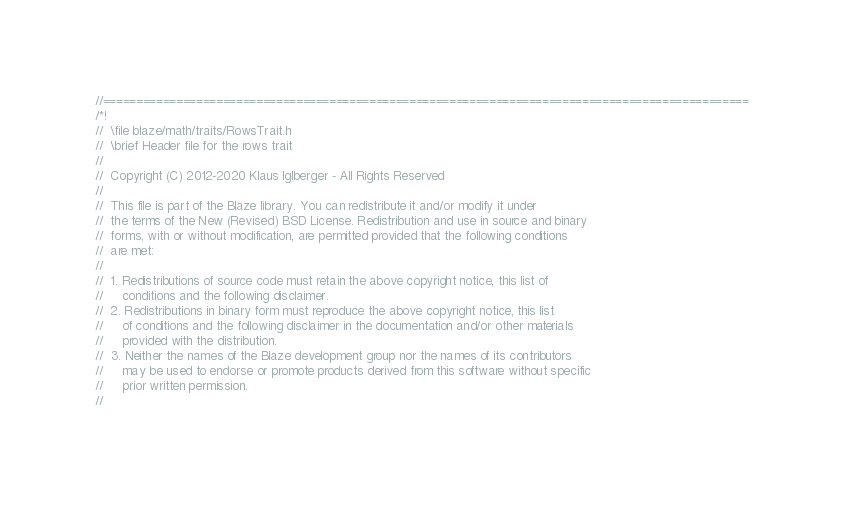<code> <loc_0><loc_0><loc_500><loc_500><_C_>//=================================================================================================
/*!
//  \file blaze/math/traits/RowsTrait.h
//  \brief Header file for the rows trait
//
//  Copyright (C) 2012-2020 Klaus Iglberger - All Rights Reserved
//
//  This file is part of the Blaze library. You can redistribute it and/or modify it under
//  the terms of the New (Revised) BSD License. Redistribution and use in source and binary
//  forms, with or without modification, are permitted provided that the following conditions
//  are met:
//
//  1. Redistributions of source code must retain the above copyright notice, this list of
//     conditions and the following disclaimer.
//  2. Redistributions in binary form must reproduce the above copyright notice, this list
//     of conditions and the following disclaimer in the documentation and/or other materials
//     provided with the distribution.
//  3. Neither the names of the Blaze development group nor the names of its contributors
//     may be used to endorse or promote products derived from this software without specific
//     prior written permission.
//</code> 